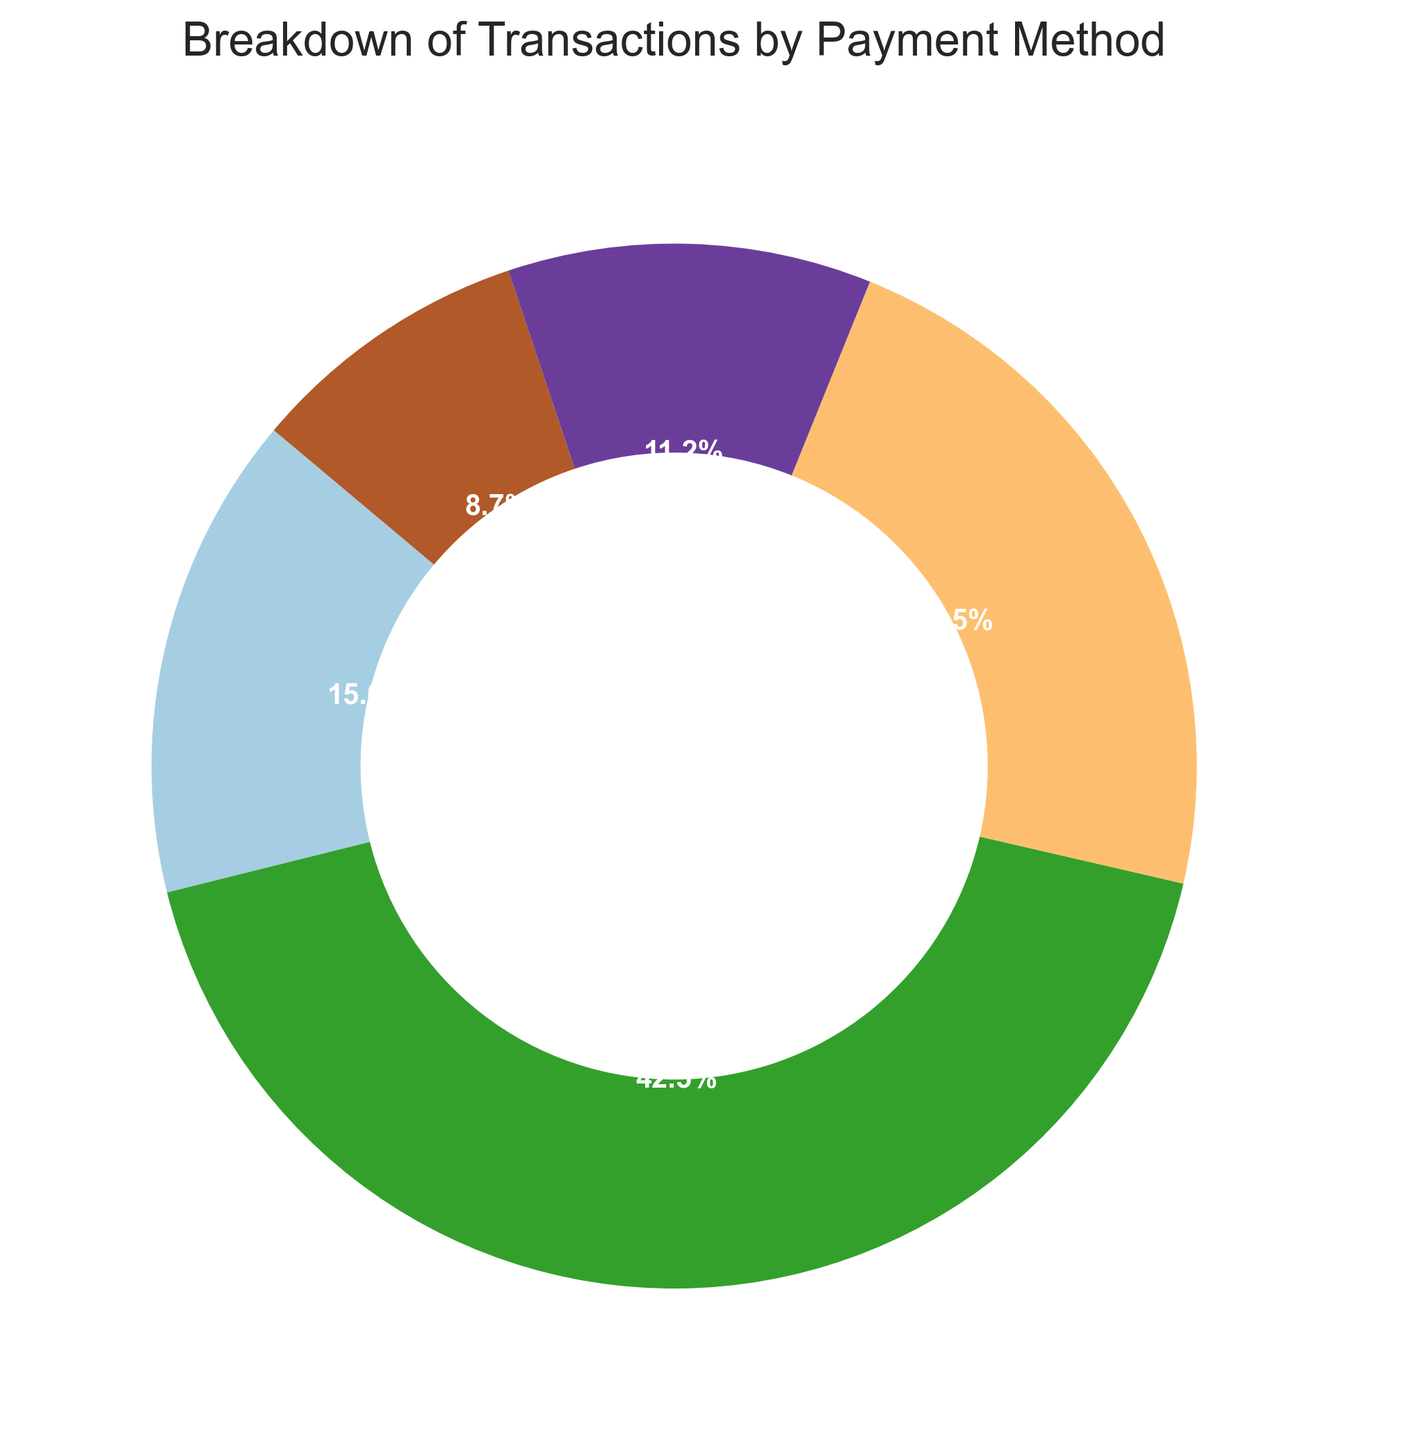What percentage of transactions were made using mobile payment? The ring chart shows the percentages directly. Locate the section labeled "Mobile Payment" and read the percentage.
Answer: 23.1% Which payment method has the highest percentage of transactions? Check the ring chart for the largest wedge. The label with the highest percentage is the one we need.
Answer: Credit Card What is the total percentage of transactions made using cash or gift card? Sum the percentages for "Cash" and "Gift Card" by locating each section in the ring chart.
Answer: 26% How does the percentage of credit card transactions compare to mobile payment transactions? Look at the percentages for both "Credit Card" and "Mobile Payment" in the ring chart and compare them.
Answer: Credit Card is larger What is the difference in transaction percentages between contactless payment and mobile payment? Subtract the percentage of "Contactless Payment" from "Mobile Payment".
Answer: 13.9% Which payment method is represented by the smallest segment, and what is its percentage? Identify the smallest wedge in the ring chart and read its label and percentage.
Answer: Gift Card, 9.0% Arrange the payment methods in descending order of their transaction percentages. List the payment methods by visually comparing the wedge sizes in the ring chart from largest to smallest.
Answer: Credit Card, Mobile Payment, Cash, Contactless Payment, Gift Card Are there more transactions made with cash or contactless payment? Compare the sizes of the "Cash" and "Contactless Payment" wedges on the ring chart.
Answer: Cash What is the percentage difference between the highest and lowest transaction methods? Find the percentages of the largest and smallest wedges, then subtract the smaller percentage from the larger one.
Answer: 55.2% What visual attribute helps you identify which payment method has the highest percentage? The size of the wedge in the ring chart visually indicates the proportion each payment method represents.
Answer: Largest wedge 